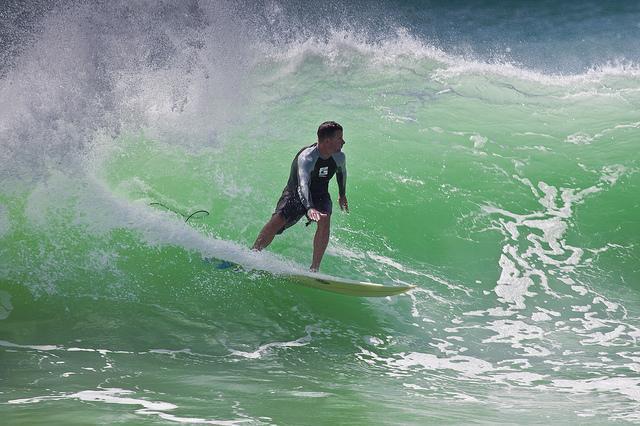How many people are in the water?
Give a very brief answer. 1. 